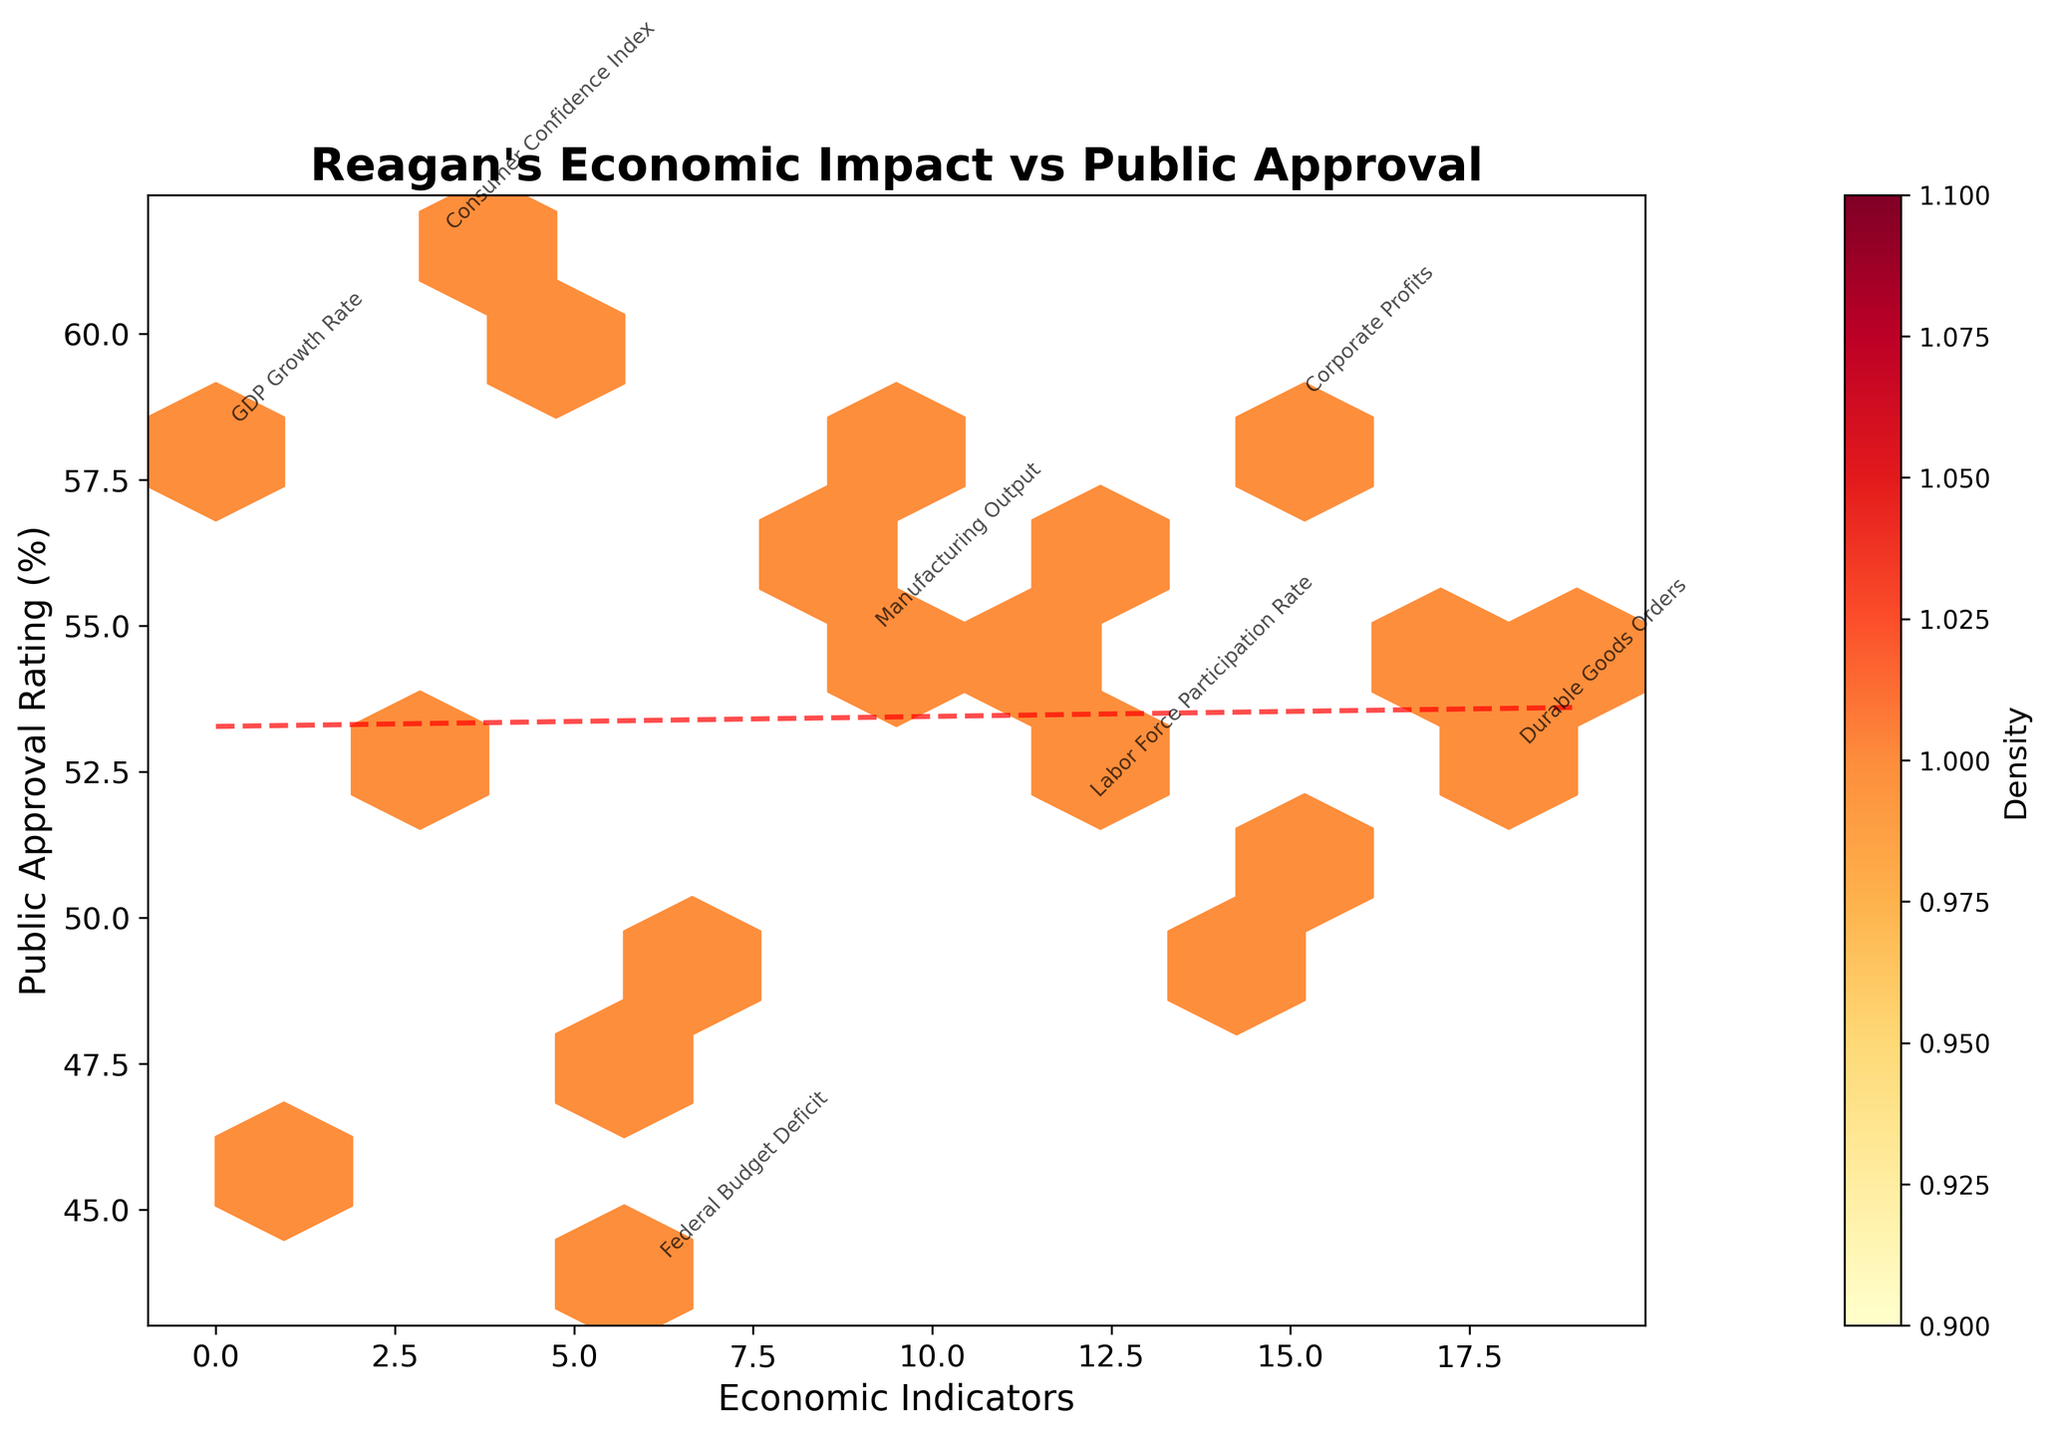What is the title of the plot? The title is at the top of the figure and summarizes the graph, indicating what the plot is about.
Answer: Reagan's Economic Impact vs Public Approval Which axis represents the Public Approval Rating? The y-axis, labeled as "Public Approval Rating (%)", represents the Public Approval Rating.
Answer: y-axis What color scheme is used in the hexbin plot? The hexbin plot uses a color scheme ranging from yellow to red, which indicates different densities within the hexagons.
Answer: Yellow to Red How many economic indicators are labeled on the hexbin plot? The labels for economic indicators are annotated on specific hexagons. By counting them, we find there are 7 labeled economic indicators.
Answer: 7 What is the range of Public Approval Ratings shown in the hexbin plot? The y-axis ranges from the minimum to the maximum Public Approval Ratings plotted. In this case, it ranges from approximately 43.9% to 61.5%.
Answer: 43.9% to 61.5% What is the relationship between economic indicators and public approval ratings as suggested by the trend line? The trend line in the plot is a red dashed line fitted to the data points. By observing its slope, we can infer that public approval ratings tend to increase as certain economic indicators improve.
Answer: Positive Correlation Which economic indicator has the closest approval rating to 58%? The data points and annotations help identify that the economic indicator ‘Stock Market Performance’ has an approval rating closest to 58%.
Answer: Stock Market Performance Is there a visible clustering of higher approval ratings around certain economic indicators? Examining the density of hexagons’ colors and their placement can show clusters. Higher approval ratings (depicted in darker red) are clustered around ‘Consumer Confidence Index’ and ‘Corporate Profits’.
Answer: Yes What can be inferred about the public approval rating for the Trade Deficit based on its rating? By locating the ‘Trade Deficit’ annotation, it can be inferred that it has a relatively lower public approval rating compared to other indicators, specifically around 47.6%.
Answer: Lower approval Does Reagan's economic policy have any significantly outlying data points in terms of public approval rating? Examining the spread and any isolated points, all data points seem to fit within the general trend, with no obvious outliers in terms of public approval rating.
Answer: No significant outliers 